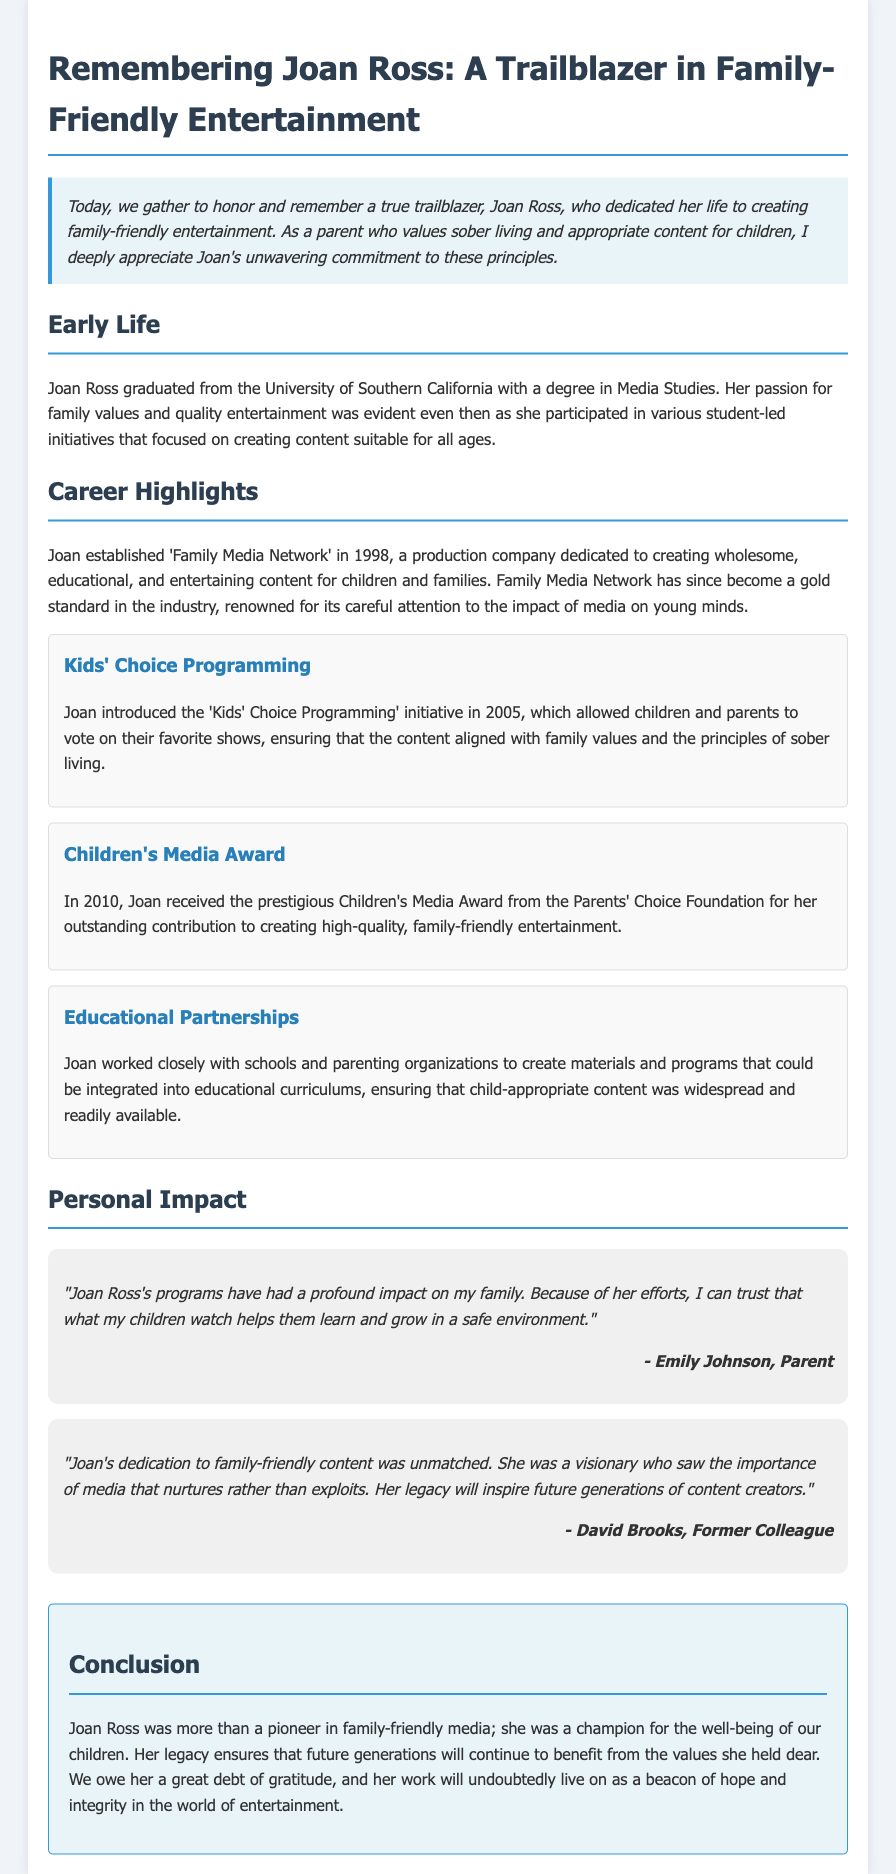What year did Joan establish the 'Family Media Network'? Joan established the 'Family Media Network' in 1998, which is mentioned in the Career Highlights section.
Answer: 1998 What award did Joan receive in 2010? The document states that Joan received the prestigious Children's Media Award from the Parents' Choice Foundation in 2010.
Answer: Children's Media Award What was the focus of the 'Kids' Choice Programming' initiative? The document explains that the initiative allowed children and parents to vote on their favorite shows, emphasizing family values and sober living.
Answer: Family values Who is quoted as saying Joan's programs had a profound impact on their family? The document cites Emily Johnson as the parent who spoke about the profound impact of Joan's programs on her family.
Answer: Emily Johnson What did Joan work on with schools and parenting organizations? According to the Career Highlights, Joan worked to create materials and programs that integrated child-appropriate content into educational curriculums.
Answer: Educational materials How did Joan's efforts benefit future generations? The conclusion states that Joan's legacy ensures that future generations will benefit from the values she held dear.
Answer: Values In what university did Joan graduate? The document mentions that Joan graduated from the University of Southern California with a degree in Media Studies.
Answer: University of Southern California What kind of content did Joan focus on creating? The document highlights that Joan focused on creating wholesome, educational, and entertaining content for children and families.
Answer: Wholesome, educational content 